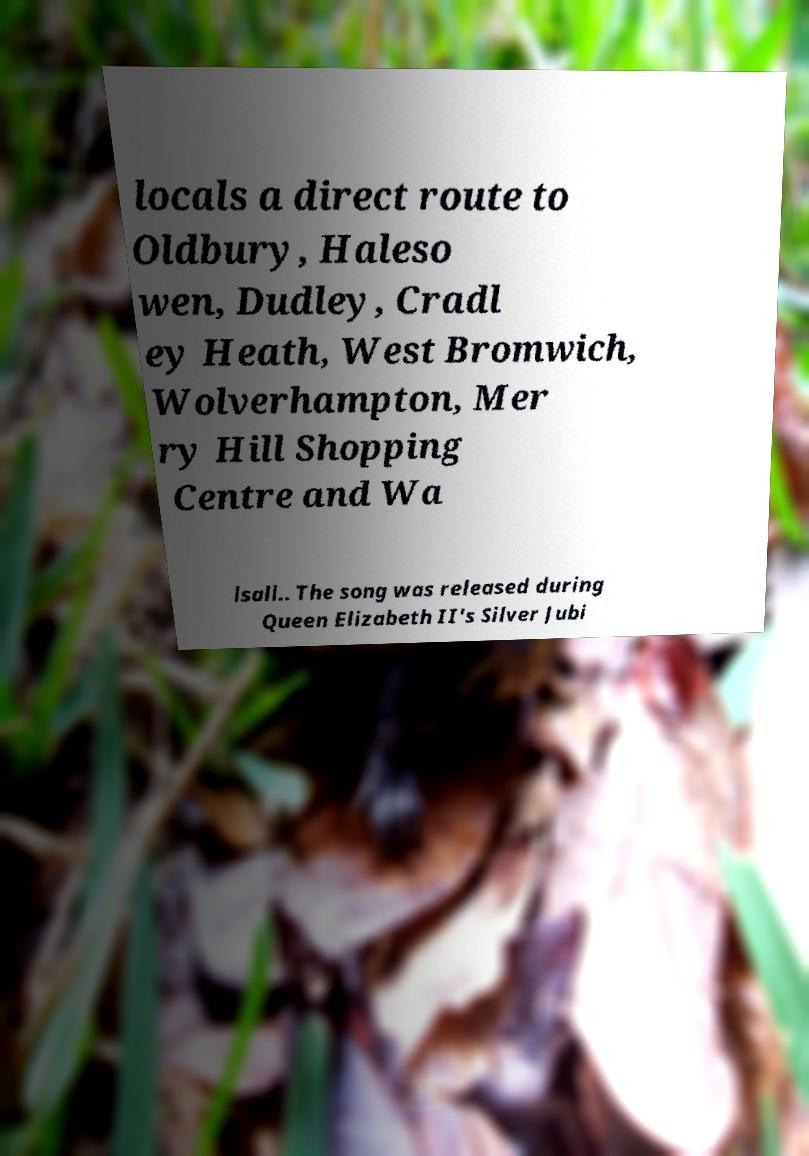I need the written content from this picture converted into text. Can you do that? locals a direct route to Oldbury, Haleso wen, Dudley, Cradl ey Heath, West Bromwich, Wolverhampton, Mer ry Hill Shopping Centre and Wa lsall.. The song was released during Queen Elizabeth II's Silver Jubi 